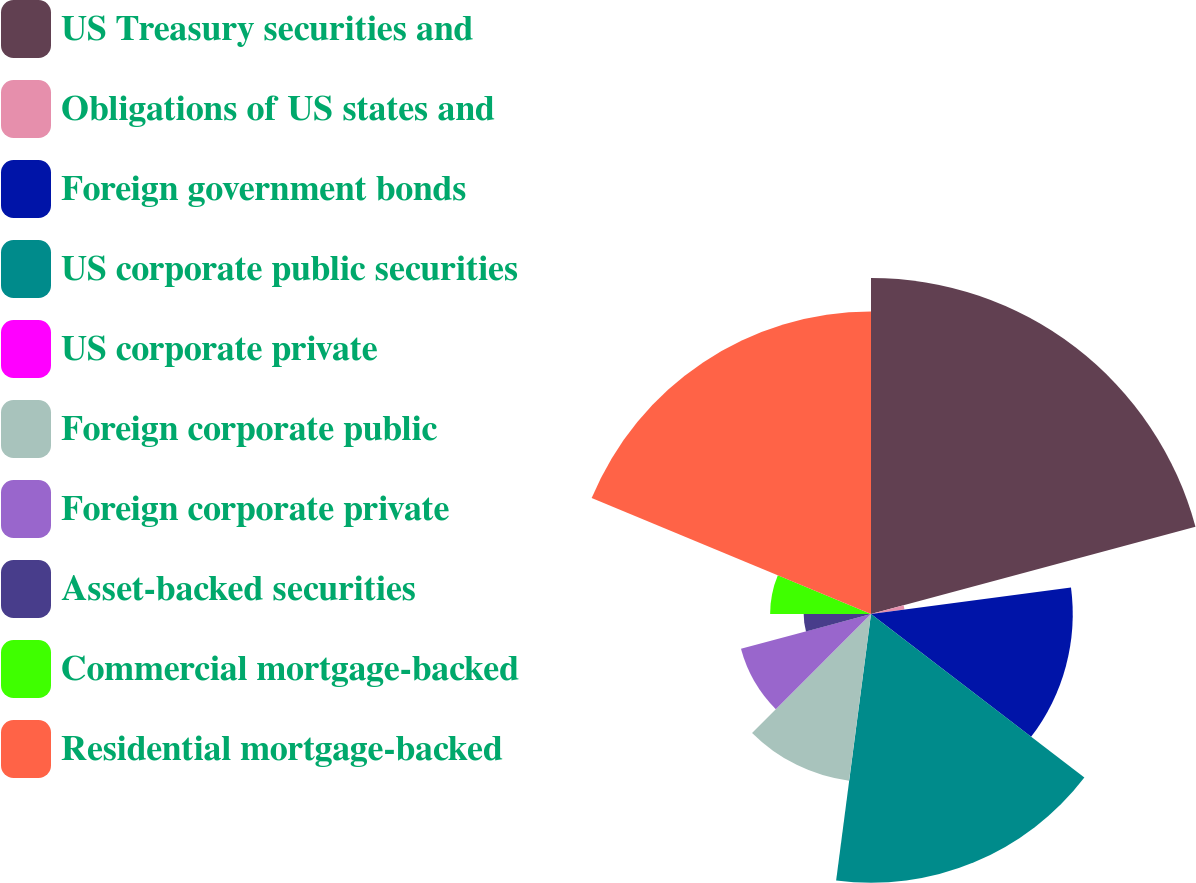<chart> <loc_0><loc_0><loc_500><loc_500><pie_chart><fcel>US Treasury securities and<fcel>Obligations of US states and<fcel>Foreign government bonds<fcel>US corporate public securities<fcel>US corporate private<fcel>Foreign corporate public<fcel>Foreign corporate private<fcel>Asset-backed securities<fcel>Commercial mortgage-backed<fcel>Residential mortgage-backed<nl><fcel>20.82%<fcel>2.09%<fcel>12.5%<fcel>16.66%<fcel>0.01%<fcel>10.42%<fcel>8.34%<fcel>4.17%<fcel>6.25%<fcel>18.74%<nl></chart> 